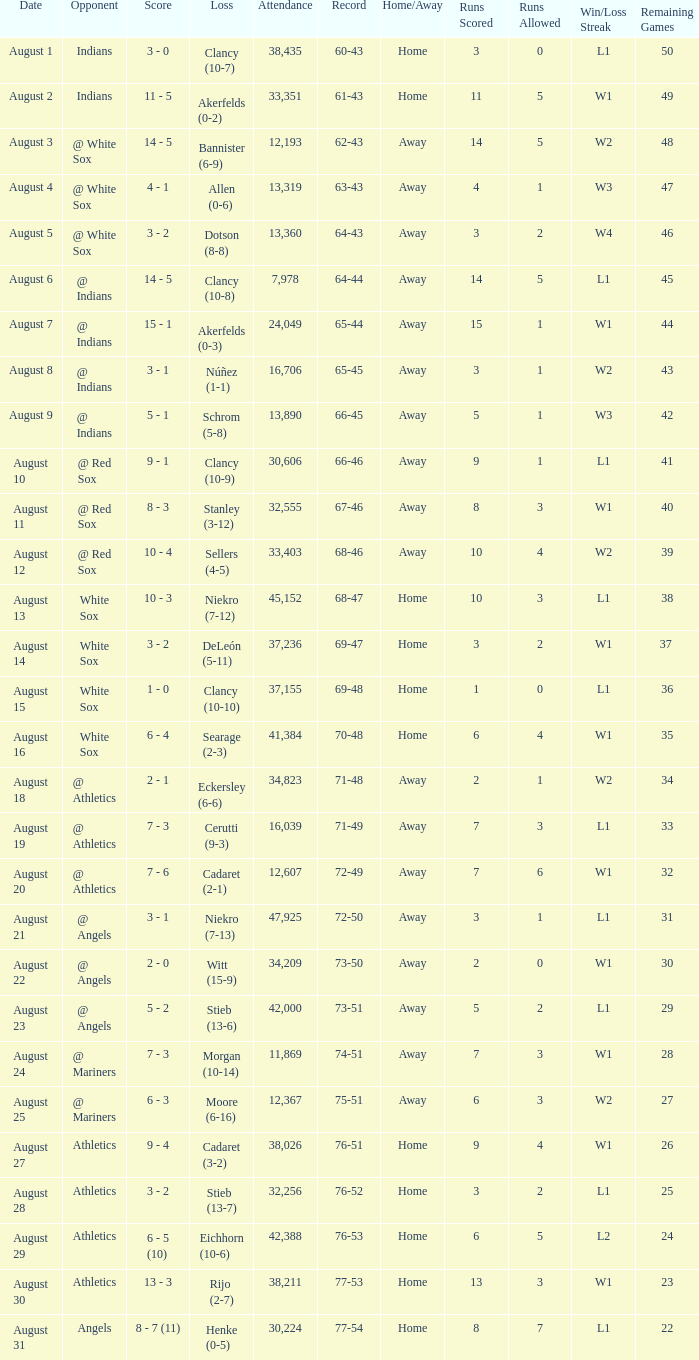What was the attendance when the record was 77-54? 30224.0. 